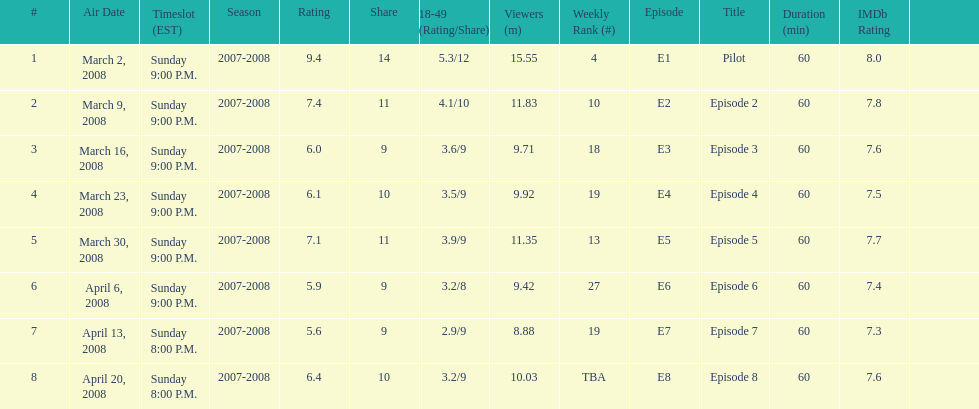How many shows had more than 10 million viewers? 4. 